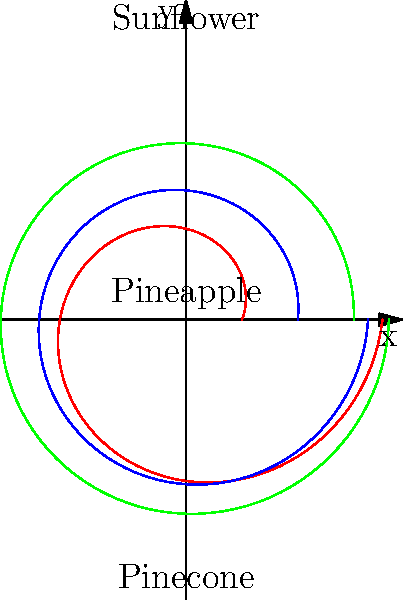The diagram shows spiral arrangements found in three different plant structures: sunflower, pineapple, and pinecone. These spirals often follow Fibonacci sequences. If we count the number of clockwise and counterclockwise spirals in each structure, which of the following is most likely to represent the Fibonacci pair $(F_n, F_{n+1})$ for the sunflower? To answer this question, we need to consider the following steps:

1. Recall that Fibonacci sequences are defined as $F_n = F_{n-1} + F_{n-2}$, with $F_0 = 0$ and $F_1 = 1$.

2. The first few numbers in the Fibonacci sequence are: 0, 1, 1, 2, 3, 5, 8, 13, 21, 34, 55, 89, 144, ...

3. In nature, spiral arrangements often follow consecutive Fibonacci numbers $(F_n, F_{n+1})$.

4. Sunflowers typically have a large number of seeds and tend to display higher Fibonacci numbers compared to pineapples or pinecones.

5. Common Fibonacci pairs observed in sunflowers include (34, 55), (55, 89), and (89, 144).

6. The pair (55, 89) is most frequently observed in mature sunflowers.

Therefore, the most likely Fibonacci pair $(F_n, F_{n+1})$ for the sunflower in this context would be (55, 89).
Answer: (55, 89) 